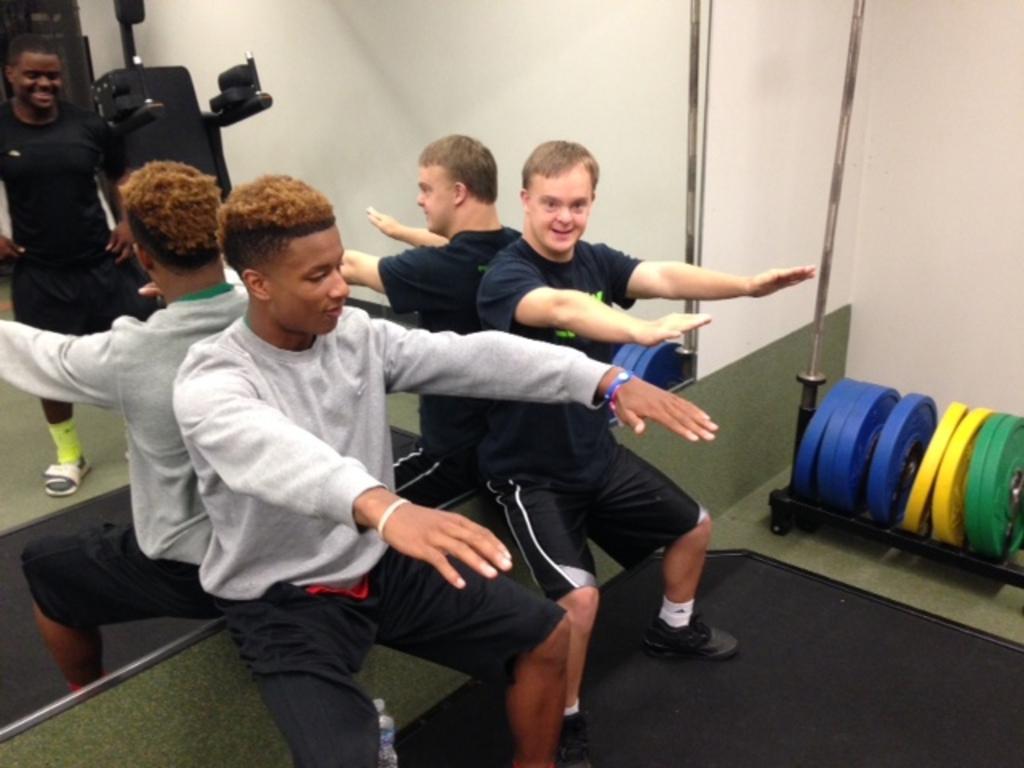Can you describe this image briefly? in this image in the center there are persons squinting and smiling and in the background on the mirror there is a reflection of the person standing and smiling and there is the reflection of the object which is black in colour and there are weights on the stand which is on the right side and there is a water bottle on the floor which is in the center. 